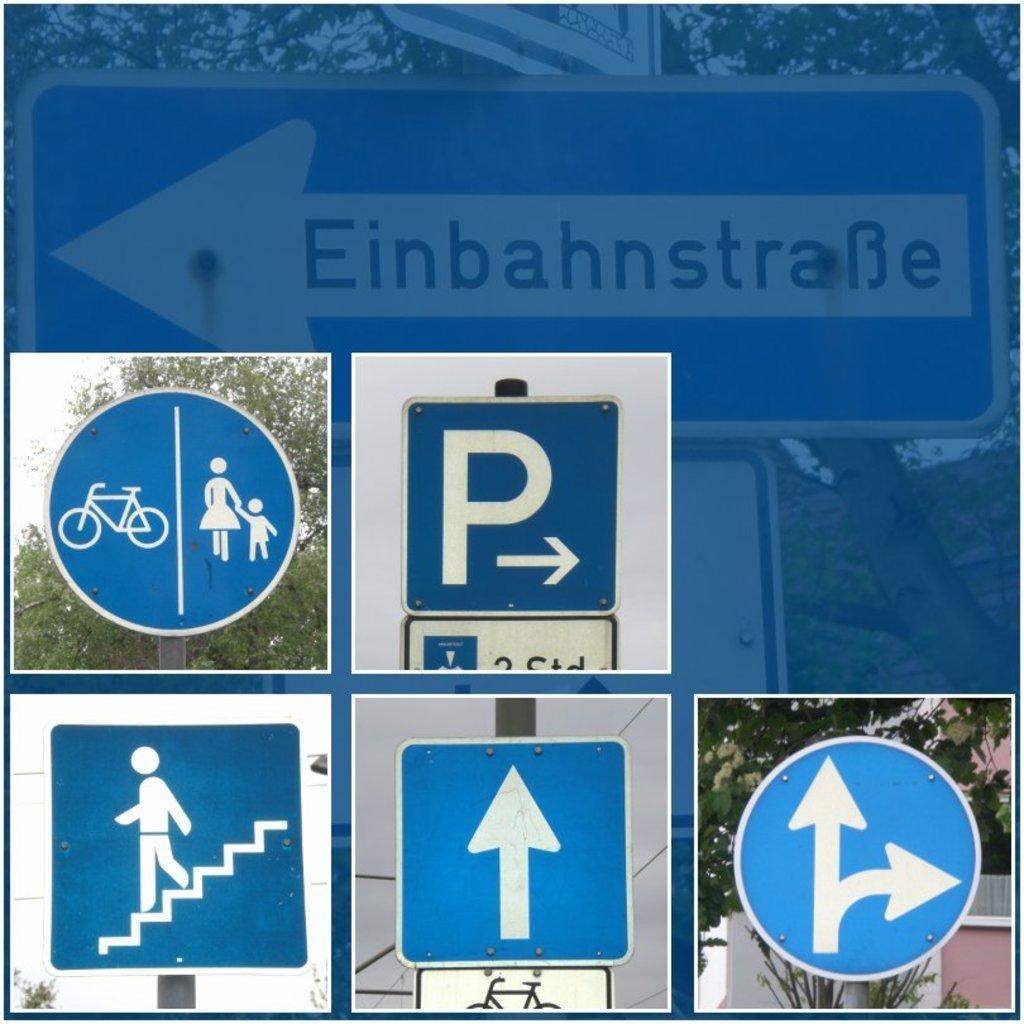In one or two sentences, can you explain what this image depicts? It is a photo collage, at the bottom on the right side. It is the sign board in blue color. On the left side there is sign board of staircase and different sign boards are there. There are trees at the backside of an image. 